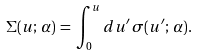Convert formula to latex. <formula><loc_0><loc_0><loc_500><loc_500>\Sigma ( u ; \, \alpha ) \, = \, \int _ { 0 } ^ { u } d u ^ { \prime } \, \sigma ( u ^ { \prime } ; \, \alpha ) .</formula> 